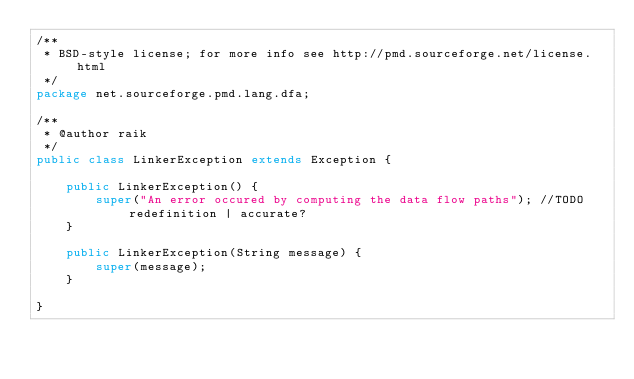Convert code to text. <code><loc_0><loc_0><loc_500><loc_500><_Java_>/**
 * BSD-style license; for more info see http://pmd.sourceforge.net/license.html
 */
package net.sourceforge.pmd.lang.dfa;

/**
 * @author raik
 */
public class LinkerException extends Exception {

    public LinkerException() {
        super("An error occured by computing the data flow paths"); //TODO redefinition | accurate?
    }

    public LinkerException(String message) {
        super(message);
    }

}
</code> 